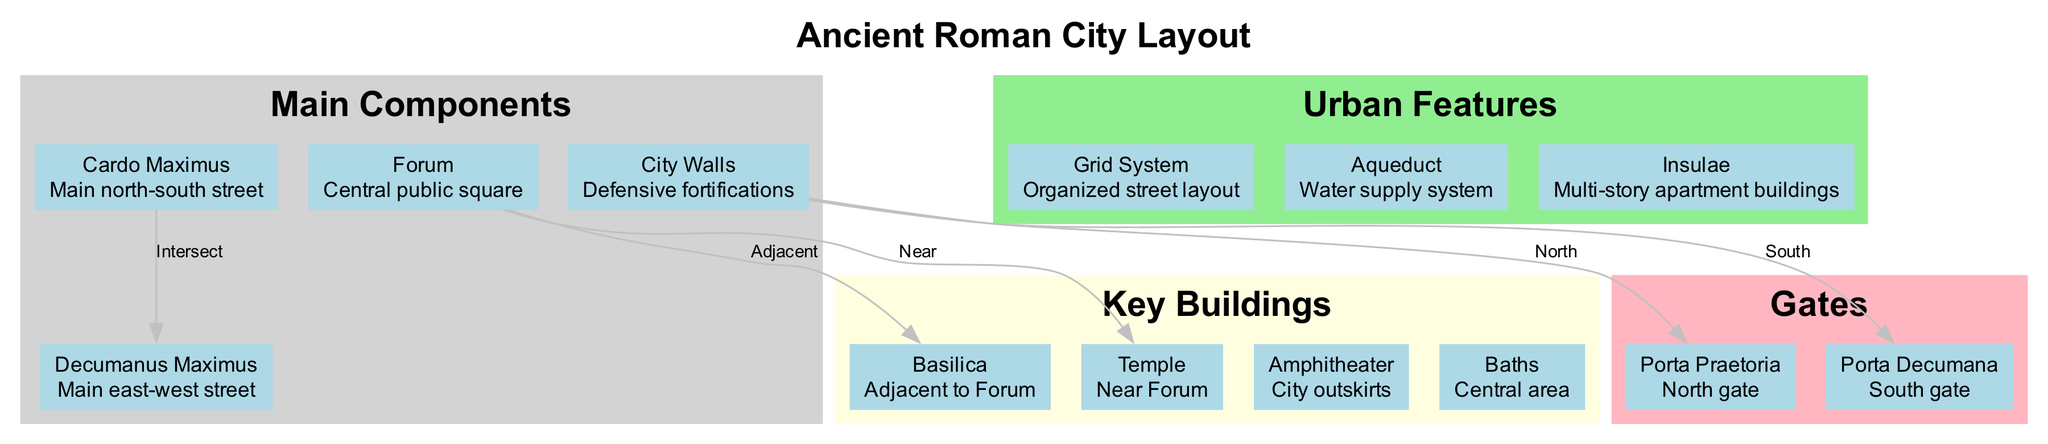What is the central public square called in the ancient Roman city layout? The diagram specifically identifies the "Forum" as the central public square, which is a key component of the city layout.
Answer: Forum Which direction does the Cardo Maximus run? According to the diagram, the Cardo Maximus is described as the main north-south street, indicating that it runs in the north-south direction.
Answer: North-South What is the location of the Amphitheater according to the diagram? The diagram notes that the Amphitheater is situated at the "City outskirts," which means it is located on the periphery of the city layout.
Answer: City outskirts How many main components are illustrated in the diagram? Upon reviewing the diagram, there are four listed main components, which include the Forum, Cardo Maximus, Decumanus Maximus, and City Walls.
Answer: Four What architectural feature is located adjacent to the Forum? The diagram states that the Basilica is adjacent to the Forum, indicating its proximity and importance in the city layout.
Answer: Basilica Which two streets intersect according to the city layout? The diagram clearly shows that the Cardo Maximus intersects with the Decumanus Maximus, representing a key point in the urban planning of the city.
Answer: Cardo Maximus and Decumanus Maximus What is the purpose of the Aqueduct as outlined in the diagram? The diagram describes the Aqueduct as a "water supply system," which serves the crucial function of providing water for the city's inhabitants.
Answer: Water supply system Where are the city gates located in relation to the city walls? The diagram indicates that the Porta Praetoria is located at the north gate and the Porta Decumana at the south gate, both being part of the City Walls' defensive structure.
Answer: North and South gates What type of urban feature is described as multi-story apartment buildings? According to the information presented in the diagram, the term "Insulae" is used to refer to multi-story apartment buildings, which were common in ancient Roman cities.
Answer: Insulae 